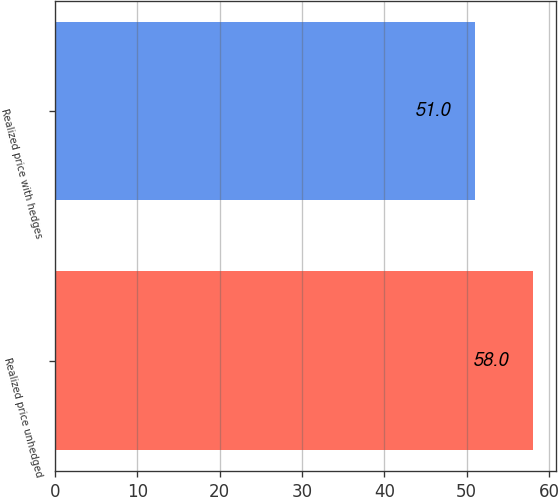Convert chart. <chart><loc_0><loc_0><loc_500><loc_500><bar_chart><fcel>Realized price unhedged<fcel>Realized price with hedges<nl><fcel>58<fcel>51<nl></chart> 